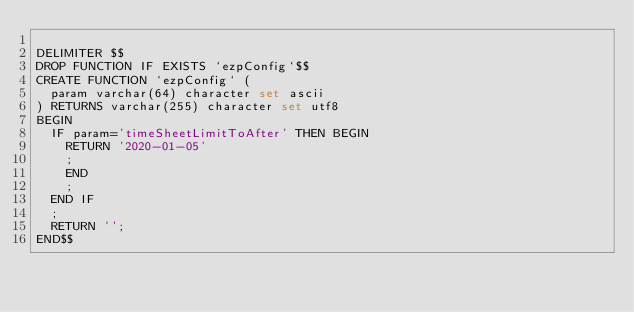<code> <loc_0><loc_0><loc_500><loc_500><_SQL_>
DELIMITER $$
DROP FUNCTION IF EXISTS `ezpConfig`$$
CREATE FUNCTION `ezpConfig` (
  param varchar(64) character set ascii
) RETURNS varchar(255) character set utf8
BEGIN
  IF param='timeSheetLimitToAfter' THEN BEGIN
    RETURN '2020-01-05'
    ;
    END
    ;
  END IF
  ;
  RETURN '';
END$$



</code> 